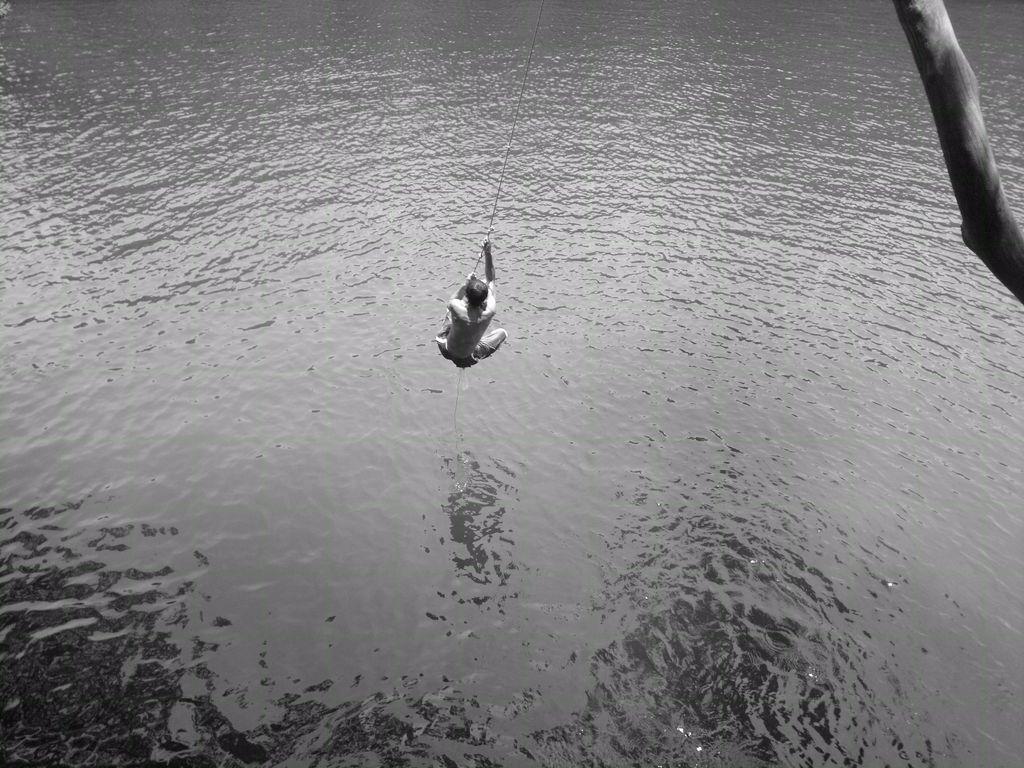Please provide a concise description of this image. In the picture we can see a man holding rope and swinging, there is water and on right side of the picture there is a branch of a tree. 